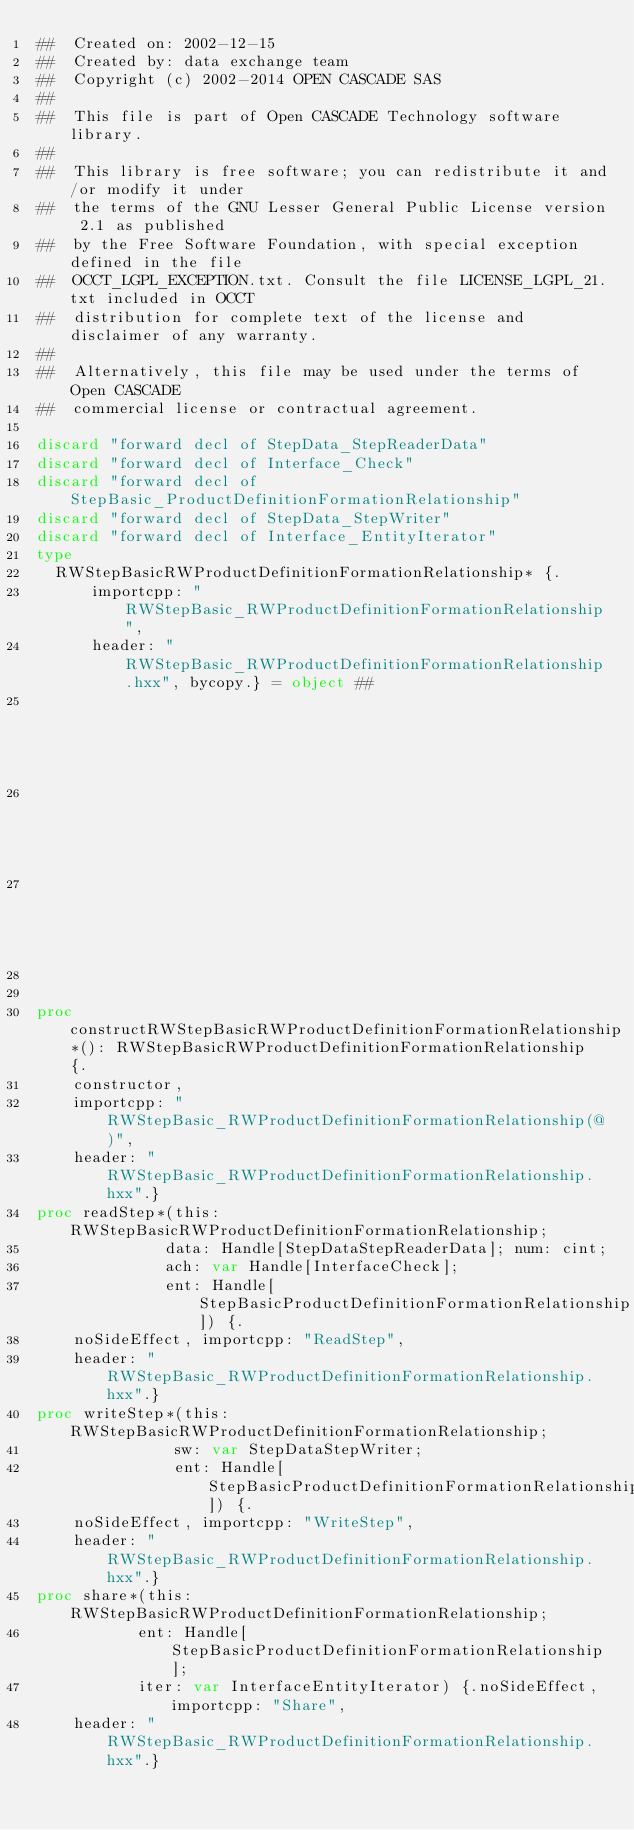Convert code to text. <code><loc_0><loc_0><loc_500><loc_500><_Nim_>##  Created on: 2002-12-15
##  Created by: data exchange team
##  Copyright (c) 2002-2014 OPEN CASCADE SAS
##
##  This file is part of Open CASCADE Technology software library.
##
##  This library is free software; you can redistribute it and/or modify it under
##  the terms of the GNU Lesser General Public License version 2.1 as published
##  by the Free Software Foundation, with special exception defined in the file
##  OCCT_LGPL_EXCEPTION.txt. Consult the file LICENSE_LGPL_21.txt included in OCCT
##  distribution for complete text of the license and disclaimer of any warranty.
##
##  Alternatively, this file may be used under the terms of Open CASCADE
##  commercial license or contractual agreement.

discard "forward decl of StepData_StepReaderData"
discard "forward decl of Interface_Check"
discard "forward decl of StepBasic_ProductDefinitionFormationRelationship"
discard "forward decl of StepData_StepWriter"
discard "forward decl of Interface_EntityIterator"
type
  RWStepBasicRWProductDefinitionFormationRelationship* {.
      importcpp: "RWStepBasic_RWProductDefinitionFormationRelationship",
      header: "RWStepBasic_RWProductDefinitionFormationRelationship.hxx", bycopy.} = object ##
                                                                                       ## !
                                                                                       ## Empty
                                                                                       ## constructor


proc constructRWStepBasicRWProductDefinitionFormationRelationship*(): RWStepBasicRWProductDefinitionFormationRelationship {.
    constructor,
    importcpp: "RWStepBasic_RWProductDefinitionFormationRelationship(@)",
    header: "RWStepBasic_RWProductDefinitionFormationRelationship.hxx".}
proc readStep*(this: RWStepBasicRWProductDefinitionFormationRelationship;
              data: Handle[StepDataStepReaderData]; num: cint;
              ach: var Handle[InterfaceCheck];
              ent: Handle[StepBasicProductDefinitionFormationRelationship]) {.
    noSideEffect, importcpp: "ReadStep",
    header: "RWStepBasic_RWProductDefinitionFormationRelationship.hxx".}
proc writeStep*(this: RWStepBasicRWProductDefinitionFormationRelationship;
               sw: var StepDataStepWriter;
               ent: Handle[StepBasicProductDefinitionFormationRelationship]) {.
    noSideEffect, importcpp: "WriteStep",
    header: "RWStepBasic_RWProductDefinitionFormationRelationship.hxx".}
proc share*(this: RWStepBasicRWProductDefinitionFormationRelationship;
           ent: Handle[StepBasicProductDefinitionFormationRelationship];
           iter: var InterfaceEntityIterator) {.noSideEffect, importcpp: "Share",
    header: "RWStepBasic_RWProductDefinitionFormationRelationship.hxx".}

























</code> 